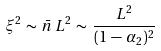Convert formula to latex. <formula><loc_0><loc_0><loc_500><loc_500>\xi ^ { 2 } \, \sim \, \bar { n } \, L ^ { 2 } \, \sim \, \frac { L ^ { 2 } } { ( 1 \, - \, \alpha _ { 2 } ) ^ { 2 } }</formula> 